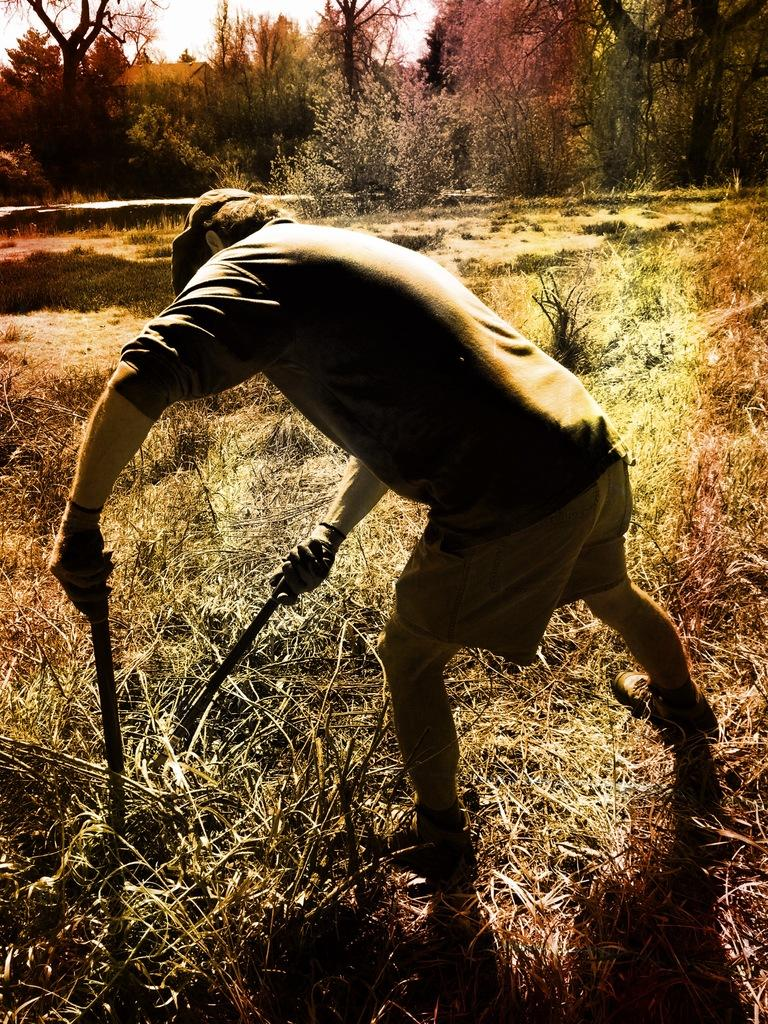What is the person in the image doing? The person is standing on the grass and holding two rods. What else can be seen in the image besides the person? There are plants, trees, a house, and the sky visible in the image. Can you describe the vegetation in the image? Yes, there are plants and trees present in the image. What is the background of the image? The background of the image includes a house and the sky. What type of space-related equipment can be seen in the image? There is no space-related equipment present in the image. What is the person's neck doing in the image? The person's neck is not doing anything in the image; it is simply part of the person's body. 